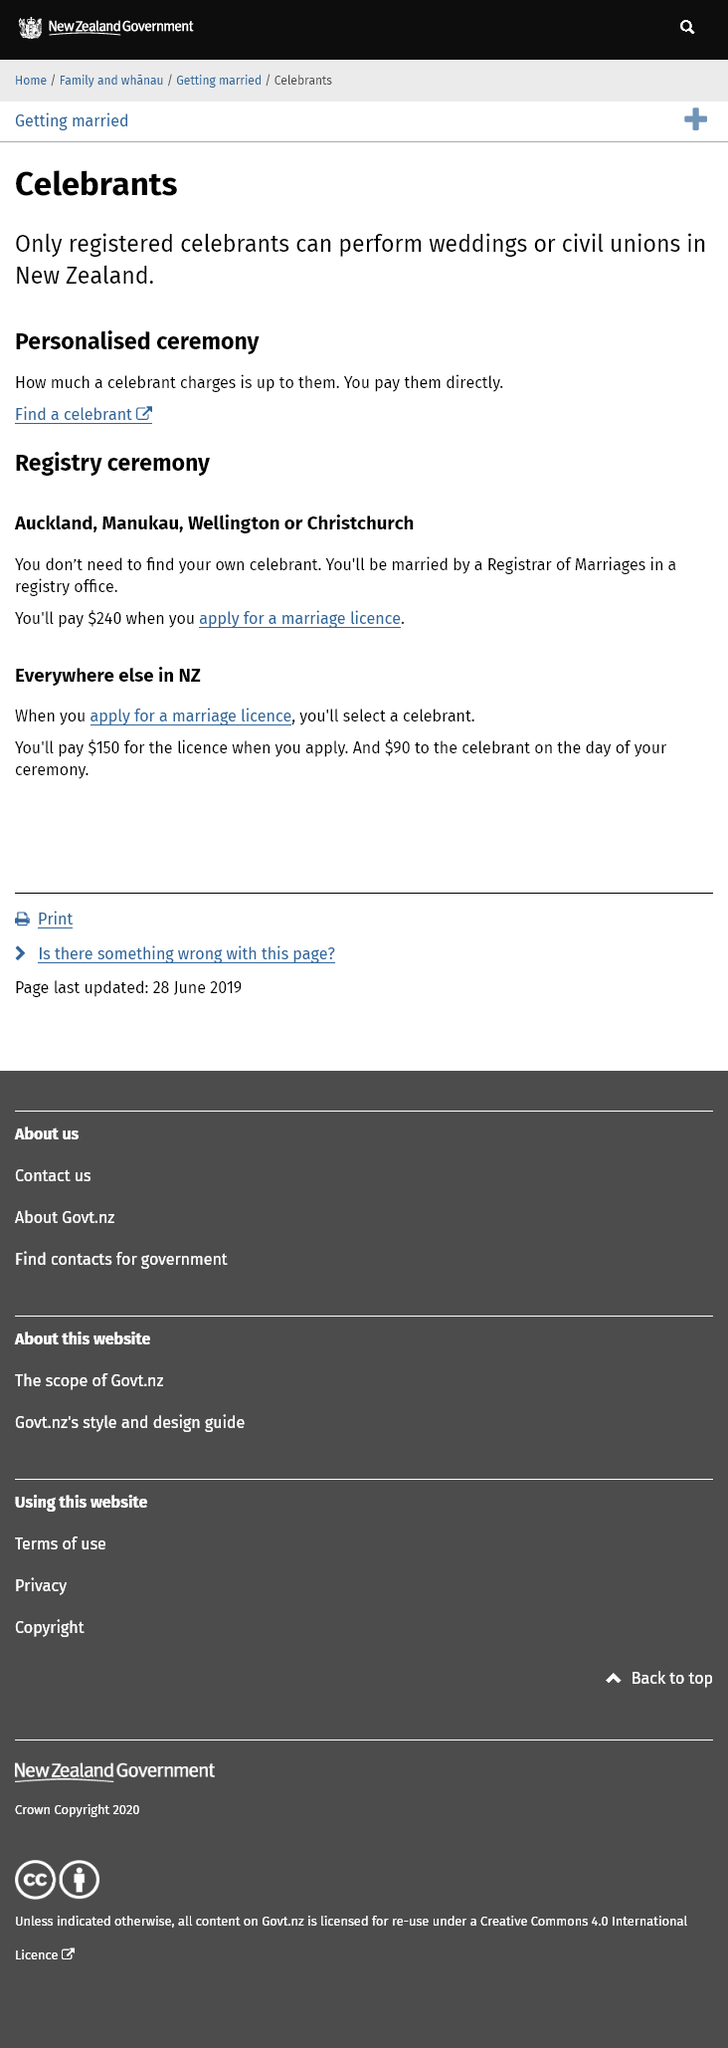Draw attention to some important aspects in this diagram. Only registered celebrants are authorized to perform weddings in New Zealand. The celebrant fee is $90 out of the total $240 fee. When you apply for a marriage license, you will pay $240. 